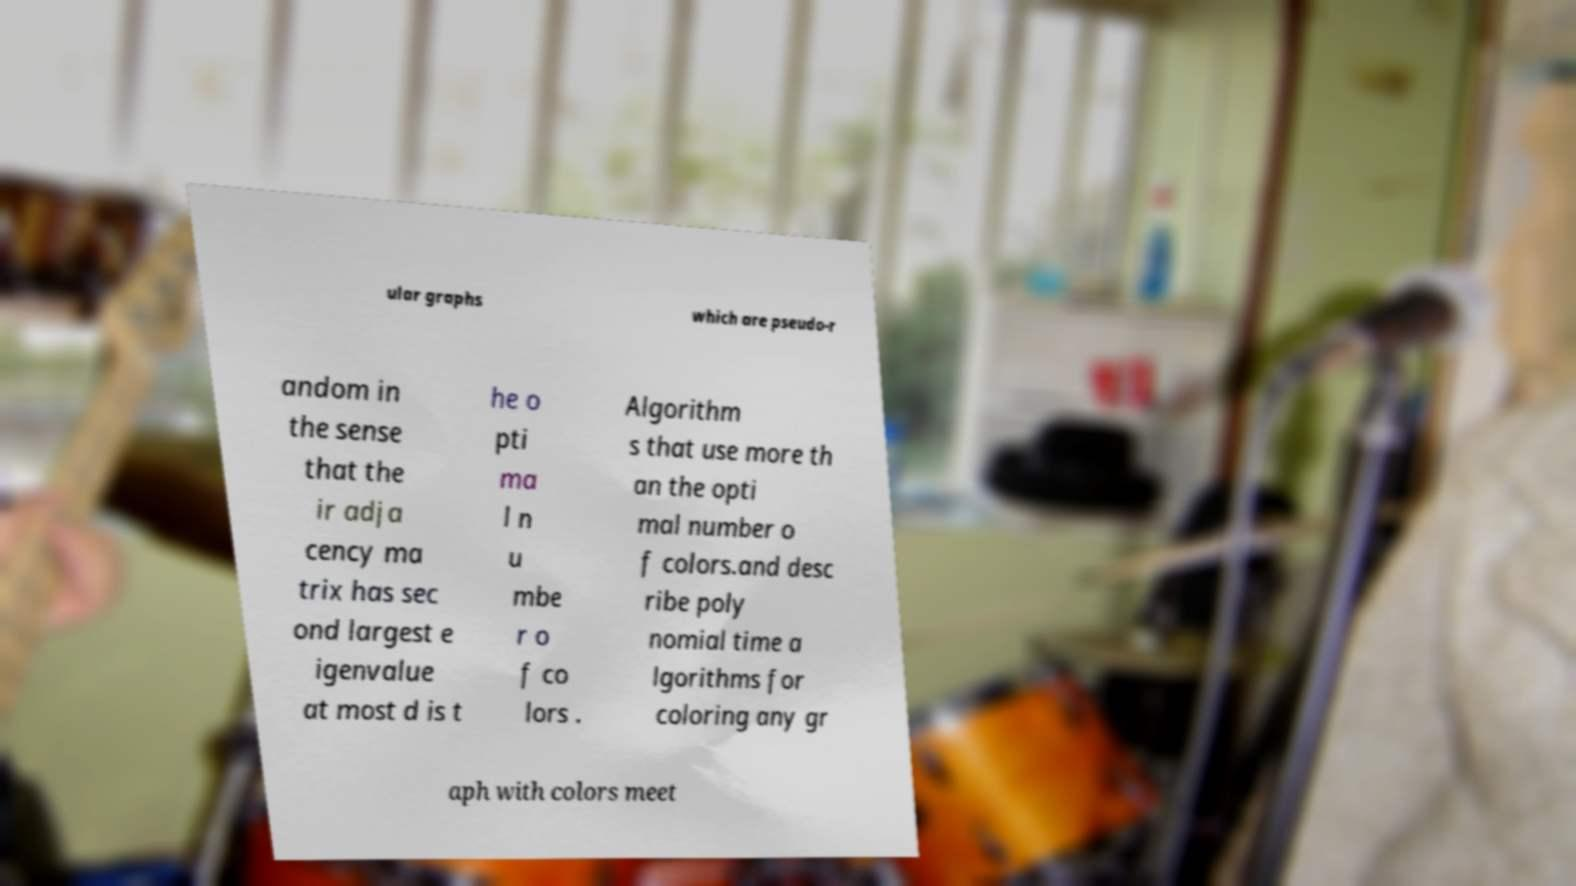Can you accurately transcribe the text from the provided image for me? ular graphs which are pseudo-r andom in the sense that the ir adja cency ma trix has sec ond largest e igenvalue at most d is t he o pti ma l n u mbe r o f co lors . Algorithm s that use more th an the opti mal number o f colors.and desc ribe poly nomial time a lgorithms for coloring any gr aph with colors meet 